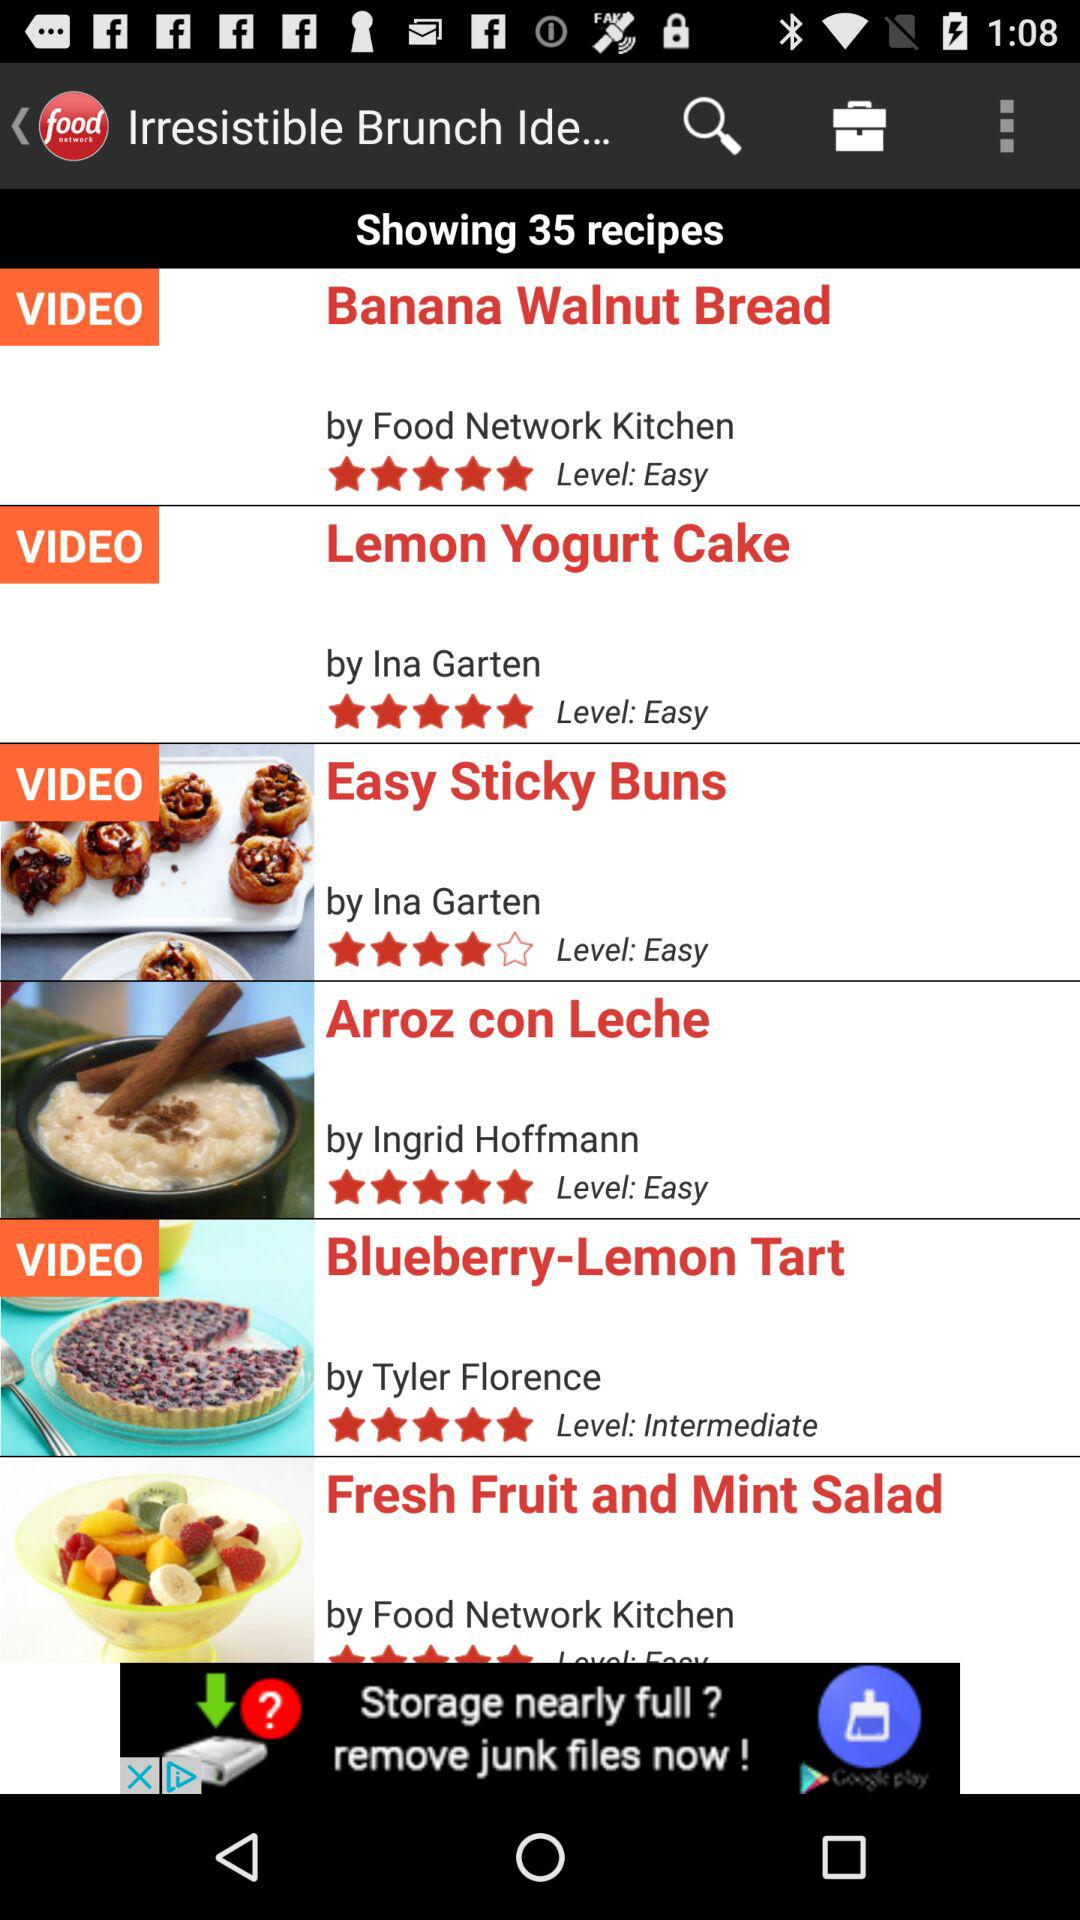How many total recipes are shown? The total recipes shown are 35. 